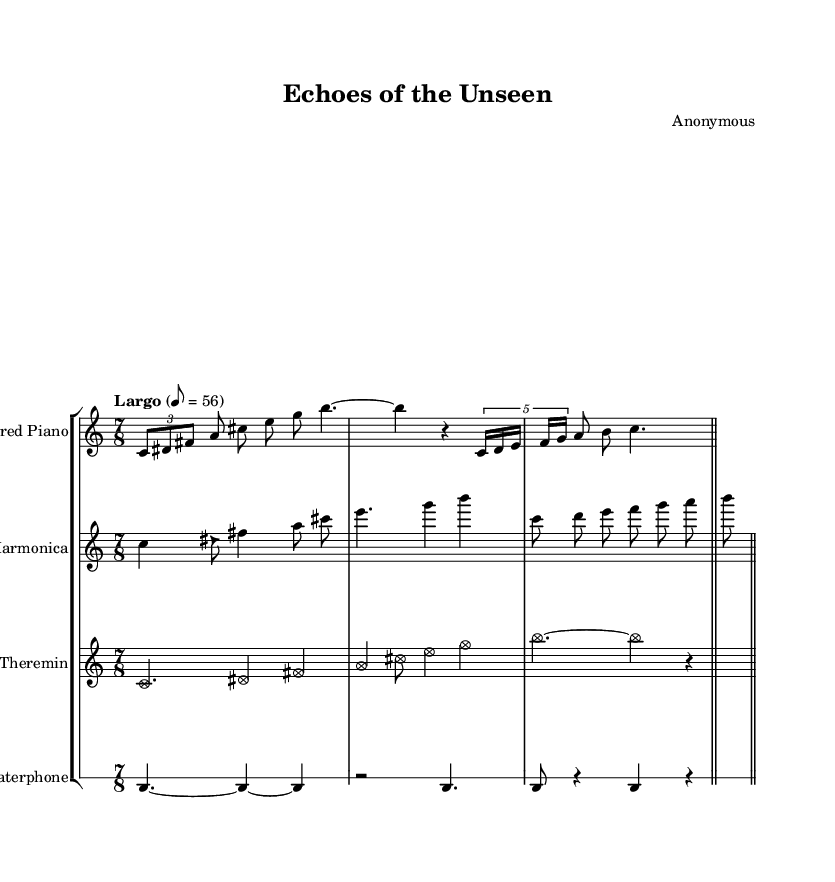What is the time signature of this music? The time signature is located at the beginning of the sheet music and is indicated as 7/8, suggesting seven beats per measure.
Answer: 7/8 What is the tempo marking indicated in the music? The tempo marking is found below the title and is indicated as "Largo" with a metronome marking of 56, informing musicians to play slowly at this tempo.
Answer: Largo, 56 Which instruments are utilized in this composition? The instruments are listed at the beginning of each staff in the score. They include Prepared Piano, Glass Harmonica, Theremin, and Waterphone.
Answer: Prepared Piano, Glass Harmonica, Theremin, Waterphone How many measures are there in the prepared piano part? By counting the bar lines in the prepared piano section, there are four measures present in this part.
Answer: 4 What kind of sound does the waterphone typically produce? The waterphone is indicated in the score with a drum staff, and is known for its ethereal and resonant sounds, often produced using bowing techniques.
Answer: Ethereal What is the primary role of the theremin in this composition? The theremin is characterized in the score with special note heads, suggesting it provides a unique melodic layer and is often used for expressive and vocal-like qualities.
Answer: Melodic layer How does the use of unconventional instruments impact the overall mood of the piece? The combination of unconventional instruments like the glass harmonica and waterphone contributes to the ambiance and evokes a sense of exploration and emotional depth, characteristic of Romantic music.
Answer: Exploration and emotional depth 